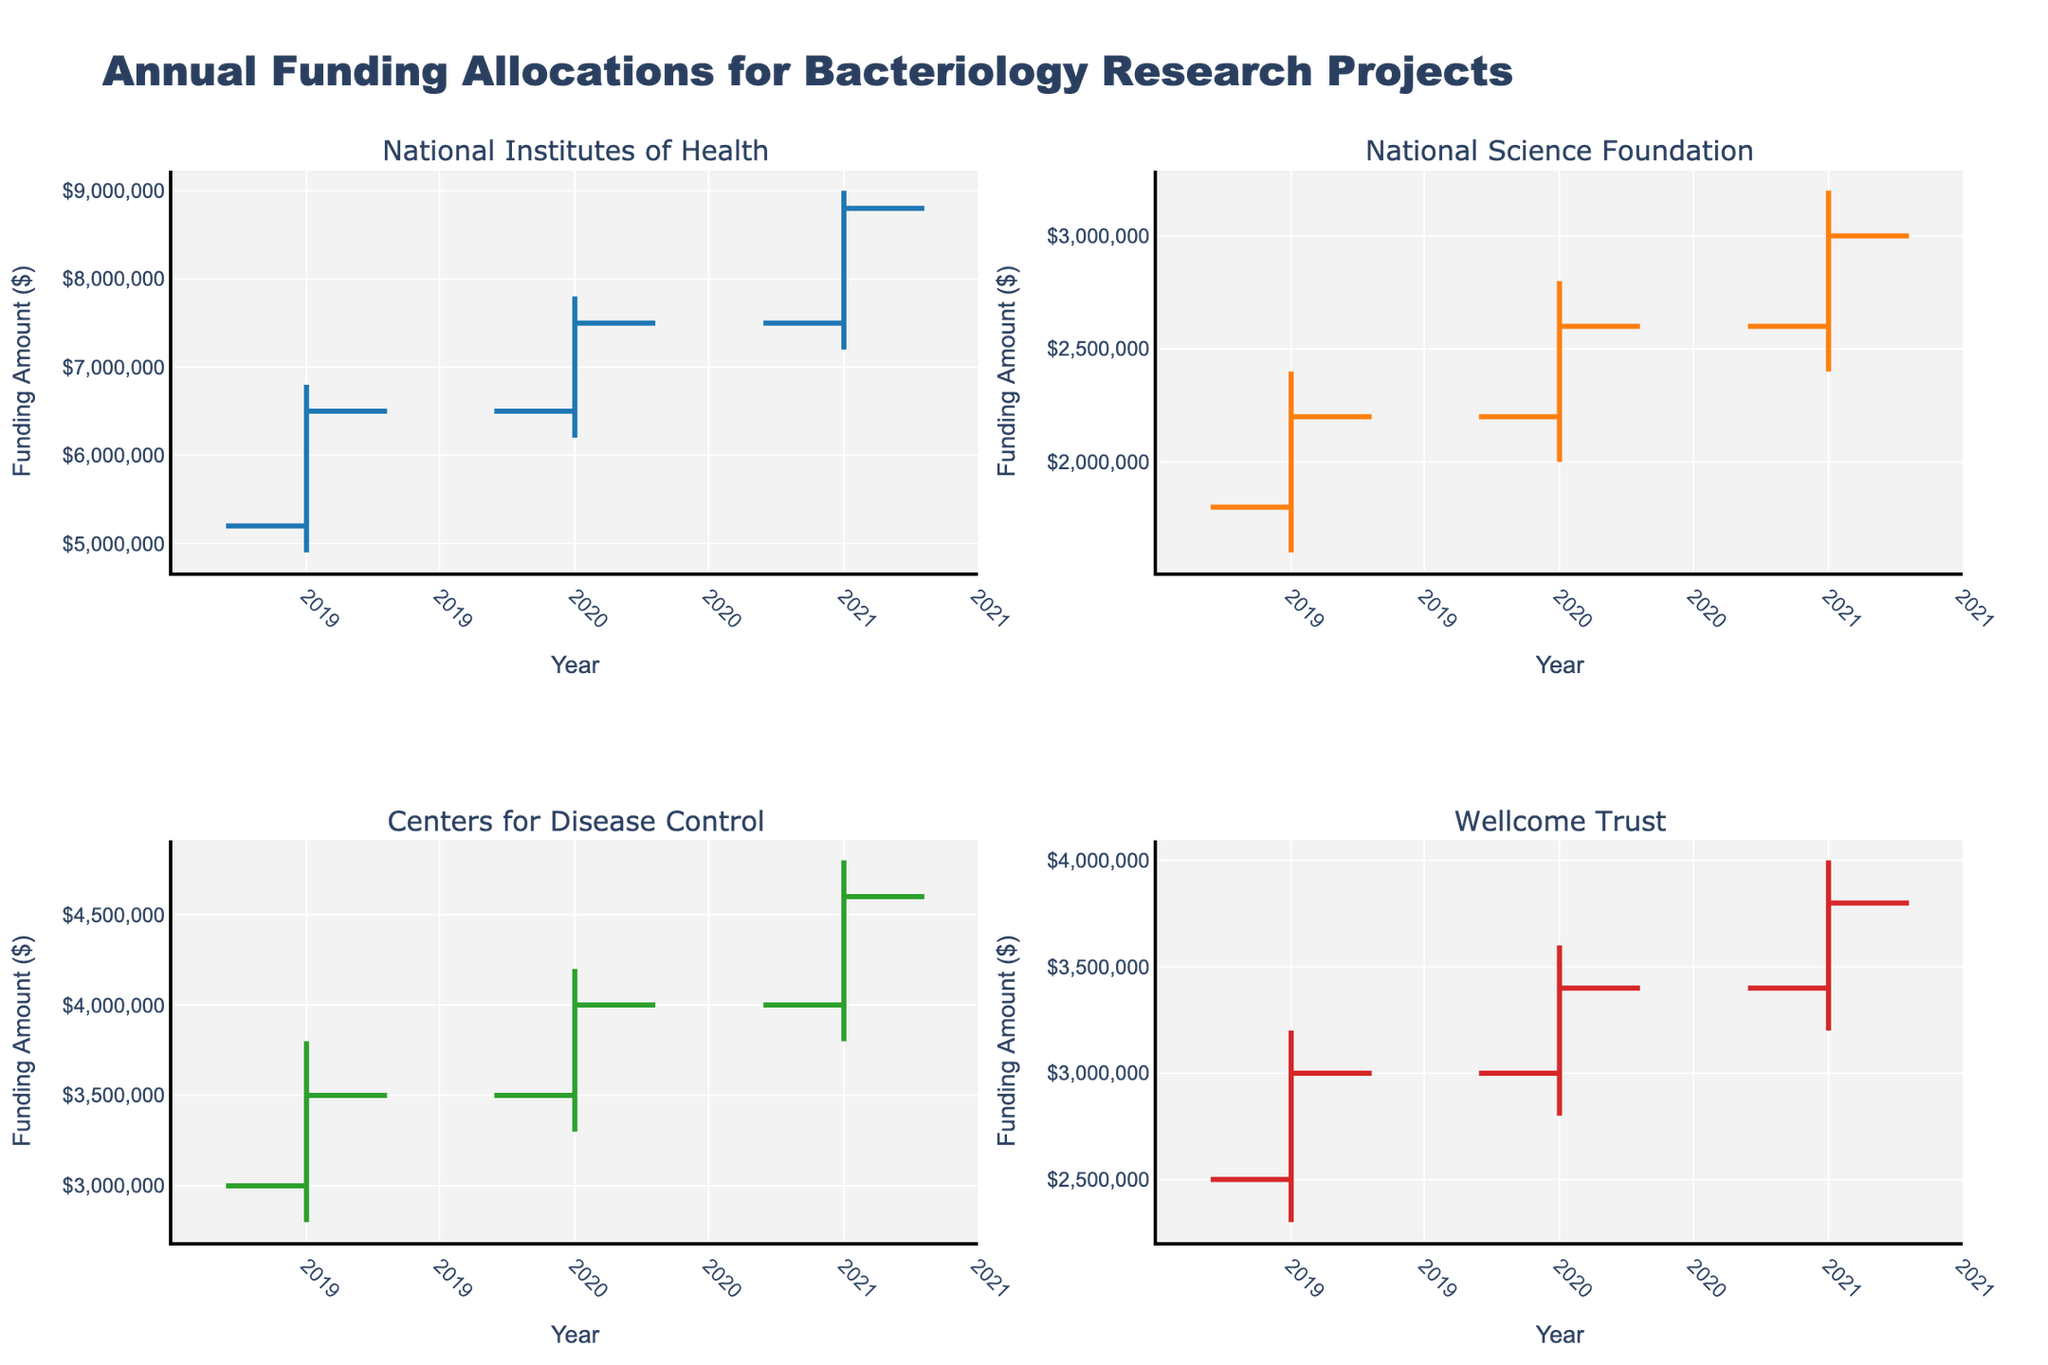What is the title of the figure? The title is usually at the top and prominently displayed. It gives a clear indication of what the data represents. In this case, the title is "Annual Funding Allocations for Bacteriology Research Projects".
Answer: Annual Funding Allocations for Bacteriology Research Projects How many funding sources are plotted in the figure? Each subplot represents a unique funding source. There are four subplots, so there must be four different funding sources.
Answer: 4 Which funding source had the highest close value in 2021? Look at the close values for each funding source in the 2021 portion of their respective subplots. The National Institutes of Health shows a close value of $8,800,000, which is the highest.
Answer: National Institutes of Health What is the funding trend for the National Institutes of Health from 2019 to 2021? Look at the open and close values for each year. In 2019, it starts at $5,200,000 and closes at $6,500,000. In 2020, it opens at $6,500,000 and closes at $7,500,000. In 2021, it opens at $7,500,000 and closes at $8,800,000. The trend is consistently increasing.
Answer: Increasing What's the average high value for the Centers for Disease Control over the three years? The high values are $3,800,000 for 2019, $4,200,000 for 2020, and $4,800,000 for 2021. Summing them gives $12,800,000 and dividing by 3 results in an average of $4,266,667.
Answer: $4,266,667 Did any funding source have a higher low value in 2020 than their high value in 2019? Compare the low values in 2020 with the high values in 2019 for each funding source. The National Institutes of Health has a low of $6,200,000 in 2020, greater than its high of $6,800,000 in 2019.
Answer: No Compare the funding range (high-low) for the National Science Foundation in 2020 and 2021. Which year had a larger range? Calculate the range by subtracting the low from the high. For 2020: $2,800,000 - $2,000,000 = $800,000. For 2021: $3,200,000 - $2,400,000 = $800,000. Both years have the same range.
Answer: Same Which year did the Wellcome Trust see the smallest increase in closing value? Look at the closing values year over year for Wellcome Trust: from 2019 ($3,000,000) to 2020 ($3,400,000) an increase of $400,000, and from 2020 to 2021 ($3,800,000), an increase of $400,000. Both years have the same increase.
Answer: Both years What is the opening value for the Centers for Disease Control in 2019, and how much did it change by the end of 2021? The opening value in 2019 for the CDC is $3,000,000. The closing value in 2021 is $4,600,000. The change is $4,600,000 - $3,000,000 = $1,600,000.
Answer: $1,600,000 